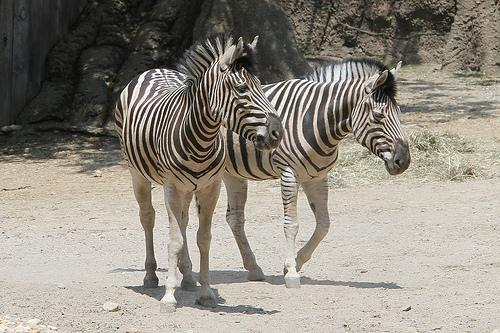Question: what kind of animals are these?
Choices:
A. Horses.
B. Deer.
C. Donkey.
D. Zebras.
Answer with the letter. Answer: D Question: how many zebras are there?
Choices:
A. Five.
B. Two.
C. Ten.
D. Eight.
Answer with the letter. Answer: B Question: what color are the zebras?
Choices:
A. Black and white.
B. Red.
C. Brown and white.
D. Purple and blue.
Answer with the letter. Answer: A Question: how is the weather?
Choices:
A. Rainy.
B. Clear.
C. Sunny.
D. Cloudy.
Answer with the letter. Answer: C Question: who is in the photo?
Choices:
A. Nobody.
B. Mother.
C. Father.
D. Granddaughter.
Answer with the letter. Answer: A 